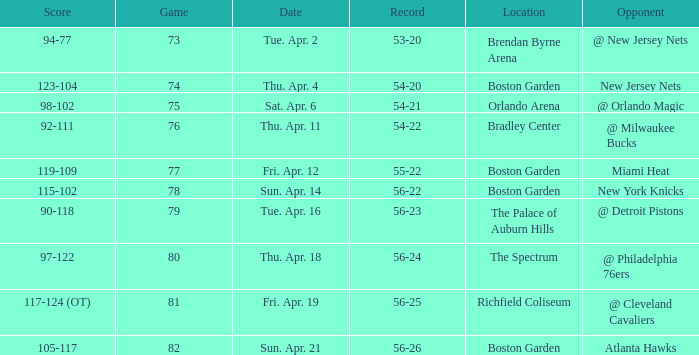Which Score has a Location of richfield coliseum? 117-124 (OT). 